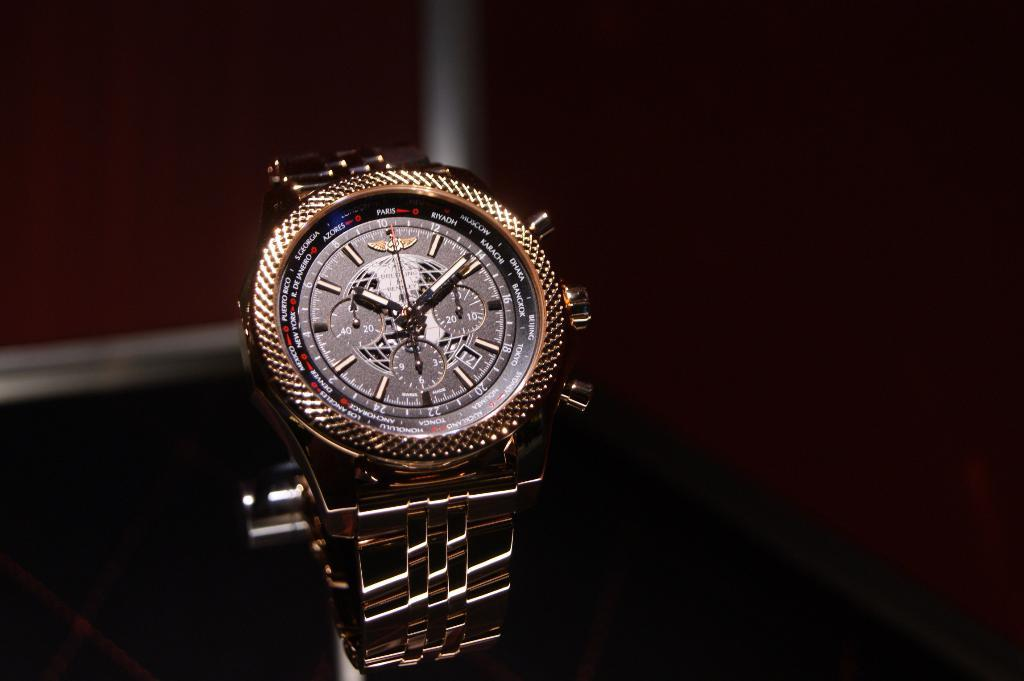What object is the main focus of the image? There is a watch in the image. What can be observed about the background of the image? The background of the image is dark. What type of theory is being discussed in the image? There is no discussion or theory present in the image; it features a watch and a dark background. Can you tell me how many mines are visible in the image? There are no mines present in the image; it features a watch and a dark background. 